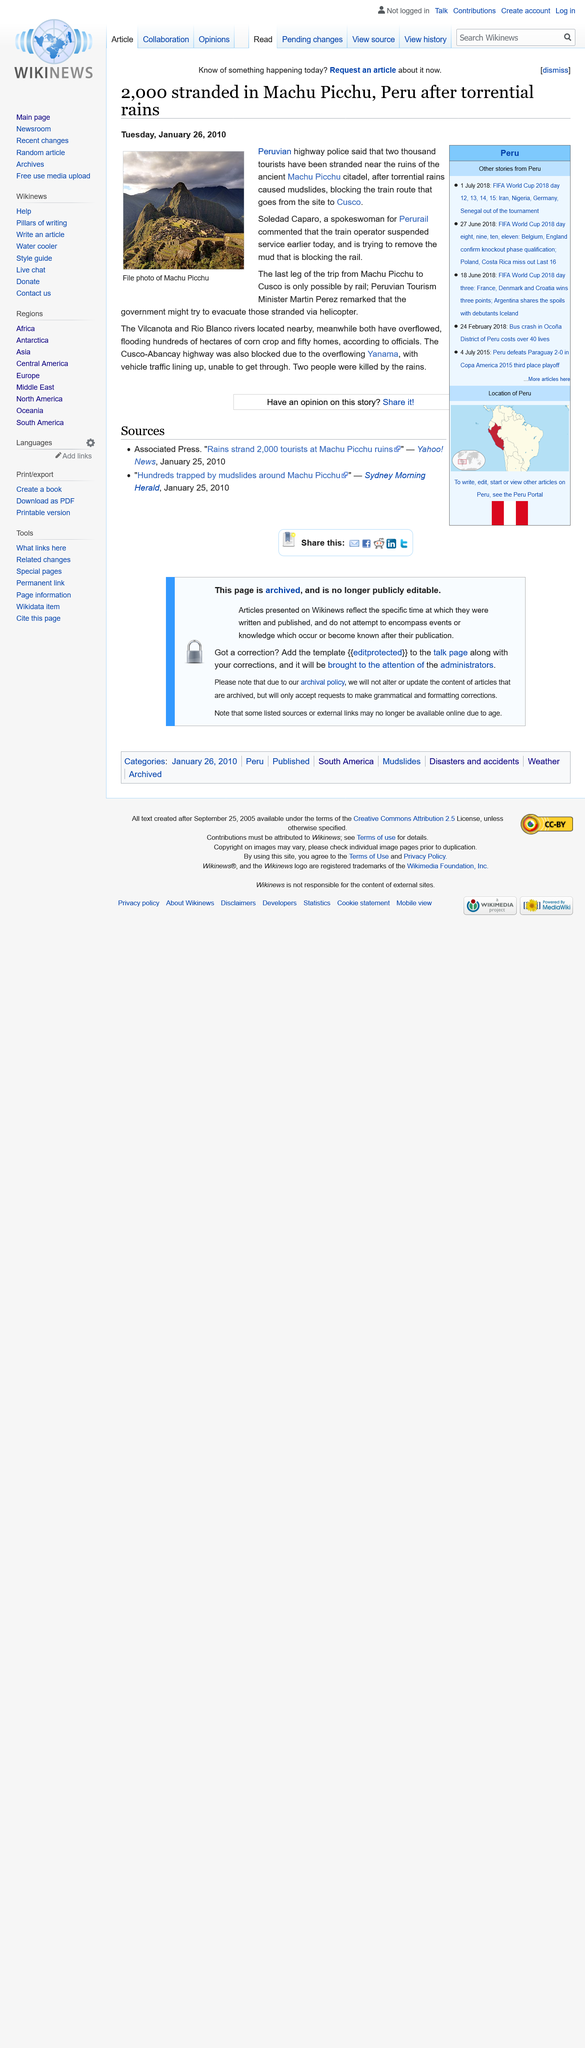Give some essential details in this illustration. This photo depicts Machu Picchu, a famous Inca citadel located in Peru. The Peruvian highway police have stated that two thousand tourists are currently stranded near Machu Picchu. The article was published on Tuesday, January 26th, 2010. 